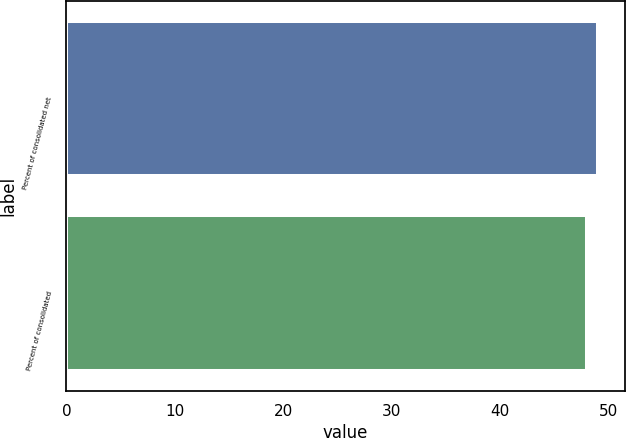Convert chart. <chart><loc_0><loc_0><loc_500><loc_500><bar_chart><fcel>Percent of consolidated net<fcel>Percent of consolidated<nl><fcel>49<fcel>48<nl></chart> 